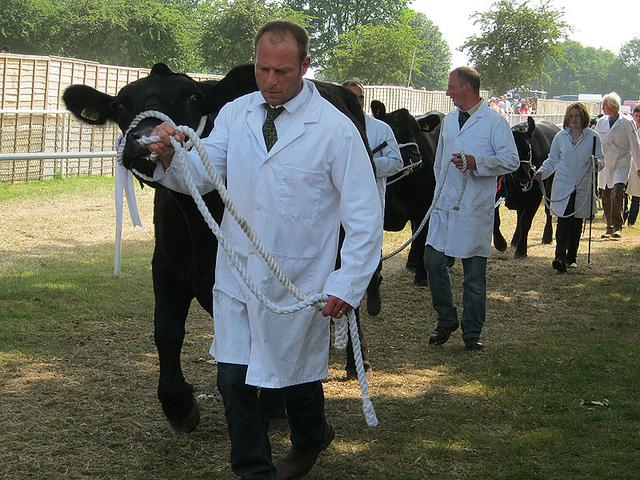Who are these grownups?

Choices:
A) cow buyers
B) medical workers
C) farmers
D) visitors medical workers 